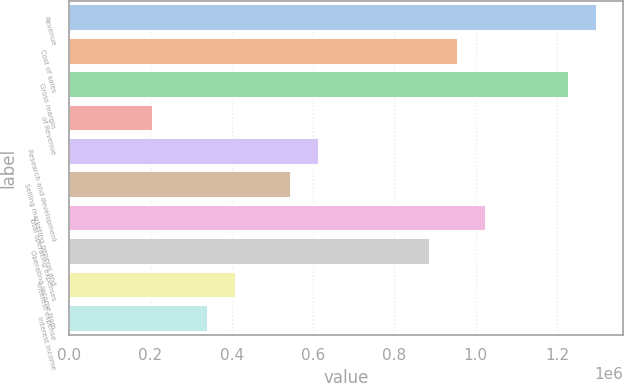<chart> <loc_0><loc_0><loc_500><loc_500><bar_chart><fcel>Revenue<fcel>Cost of sales<fcel>Gross margin<fcel>of Revenue<fcel>Research and development<fcel>Selling marketing general and<fcel>Total operating expenses<fcel>Operating income from<fcel>Interest expense<fcel>Interest income<nl><fcel>1.29775e+06<fcel>956236<fcel>1.22945e+06<fcel>204908<fcel>614723<fcel>546421<fcel>1.02454e+06<fcel>887934<fcel>409816<fcel>341513<nl></chart> 